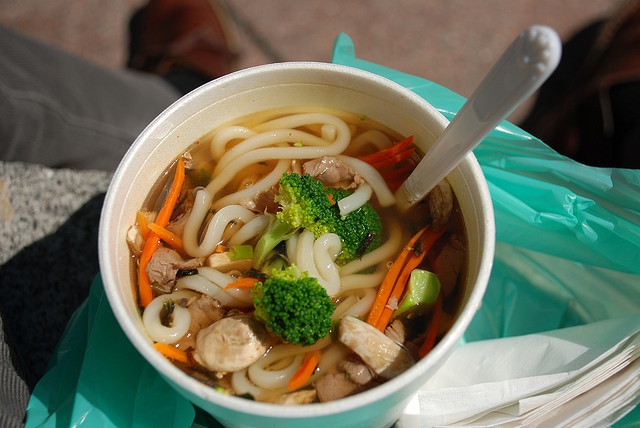Describe the objects in this image and their specific colors. I can see cup in gray, tan, olive, maroon, and black tones, bowl in gray, tan, olive, and maroon tones, people in gray, black, and maroon tones, spoon in gray, darkgray, and olive tones, and broccoli in gray, olive, darkgreen, and black tones in this image. 